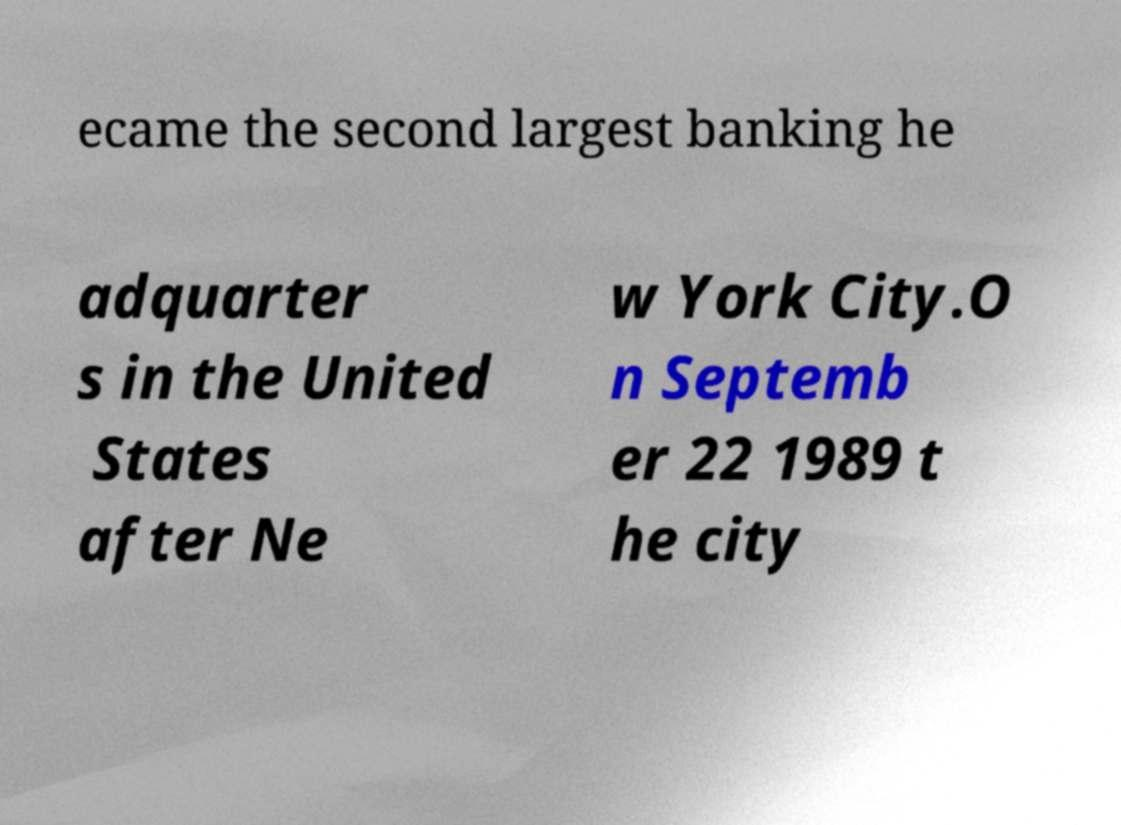I need the written content from this picture converted into text. Can you do that? ecame the second largest banking he adquarter s in the United States after Ne w York City.O n Septemb er 22 1989 t he city 